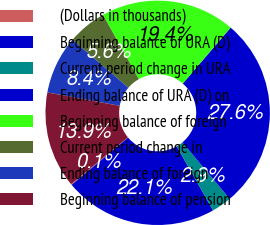<chart> <loc_0><loc_0><loc_500><loc_500><pie_chart><fcel>(Dollars in thousands)<fcel>Beginning balance of URA (D)<fcel>Current period change in URA<fcel>Ending balance of URA (D) on<fcel>Beginning balance of foreign<fcel>Current period change in<fcel>Ending balance of foreign<fcel>Beginning balance of pension<nl><fcel>0.12%<fcel>22.13%<fcel>2.87%<fcel>27.64%<fcel>19.38%<fcel>5.62%<fcel>8.37%<fcel>13.88%<nl></chart> 